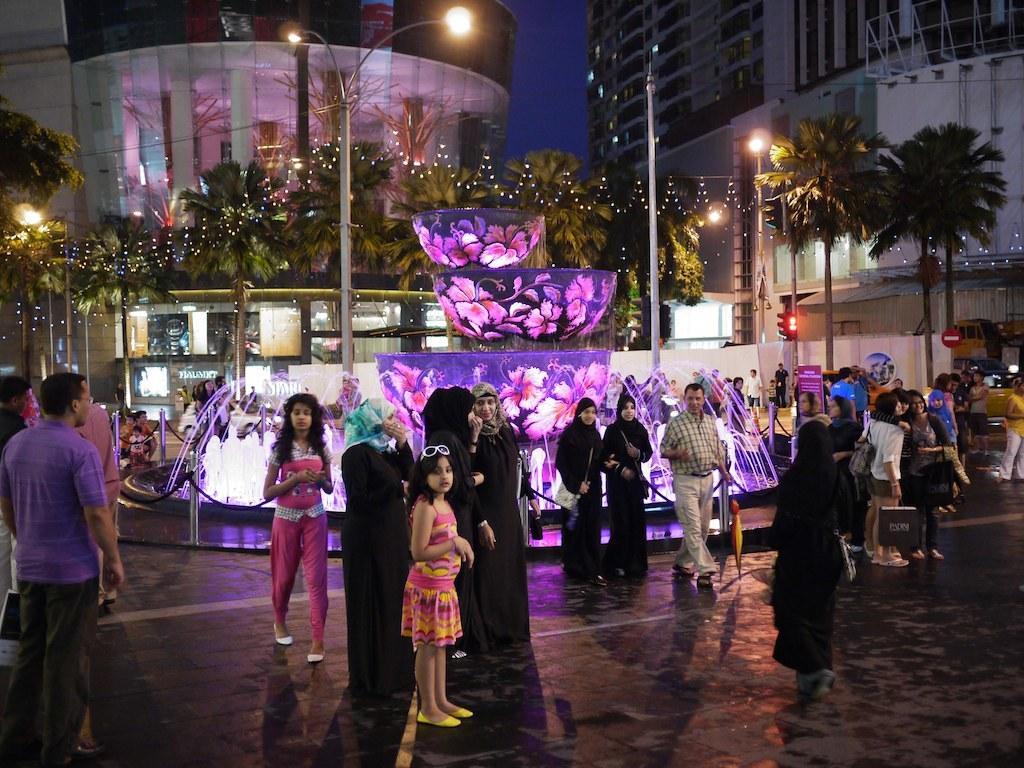Describe this image in one or two sentences. This is an image clicked in the dark. Here I can see many people standing on the road. At the back of these people there is a fountain. In the background, I can see few poles, trees and buildings. 